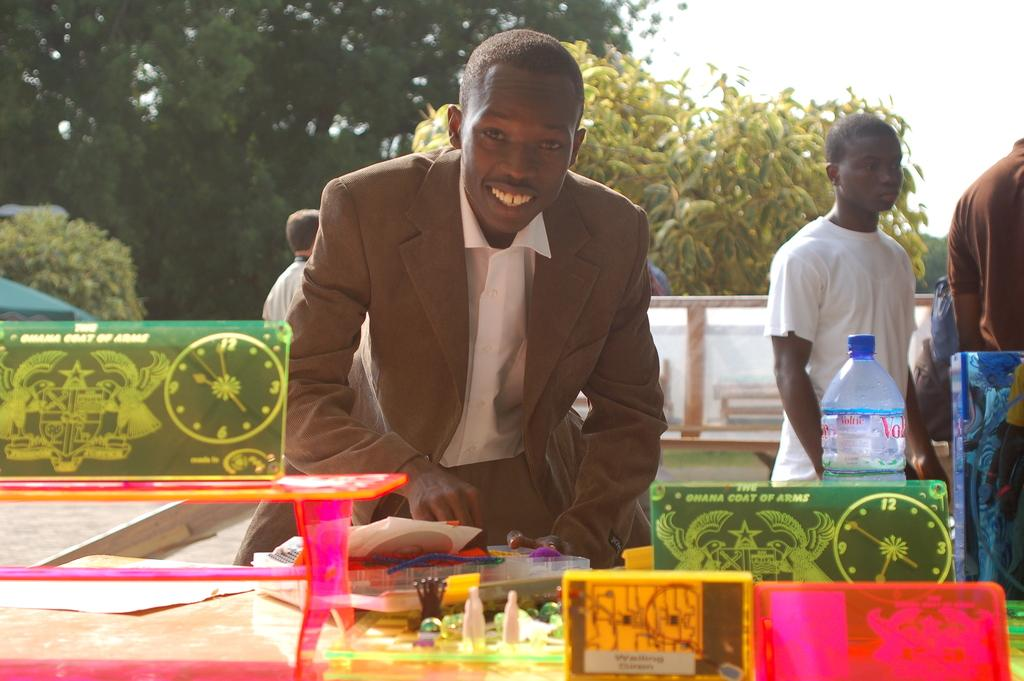What can be seen in the background of the image? There are multiple trees in the distance. How is the person in the image dressed, and what is their expression? The person is wearing a suit and smiling. What is on the table in the image? There is a bottle and unspecified things on the table. Are there any other people visible in the image? Yes, there are people standing in the distance. What is the person's opinion on the liquid in the bottle? There is no information about the person's opinion on the liquid in the bottle, as the image does not provide any context for their thoughts or feelings. 